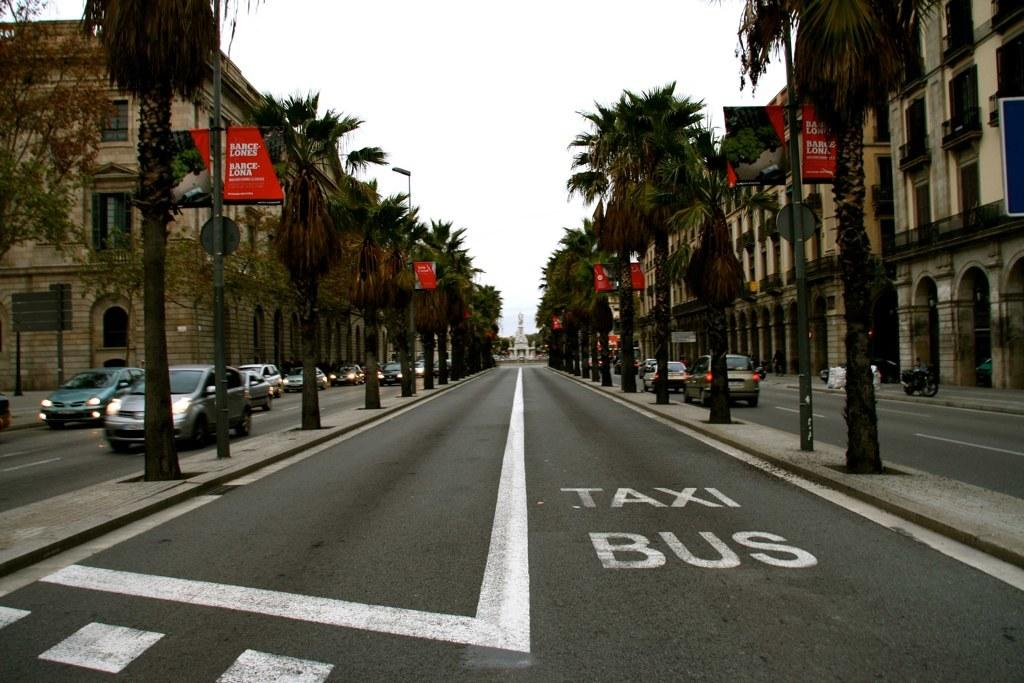What can be seen on both sides of the image? Vehicles, trees, and buildings can be seen on both the right and left sides of the image. What is located in the center of the image? There is a road and a pillar in the center of the image. What is visible in the background of the image? The sky is visible in the background of the image. What is the weight of the quartz in the image? There is no quartz present in the image. How many hooks can be seen in the image? There are no hooks present in the image. 